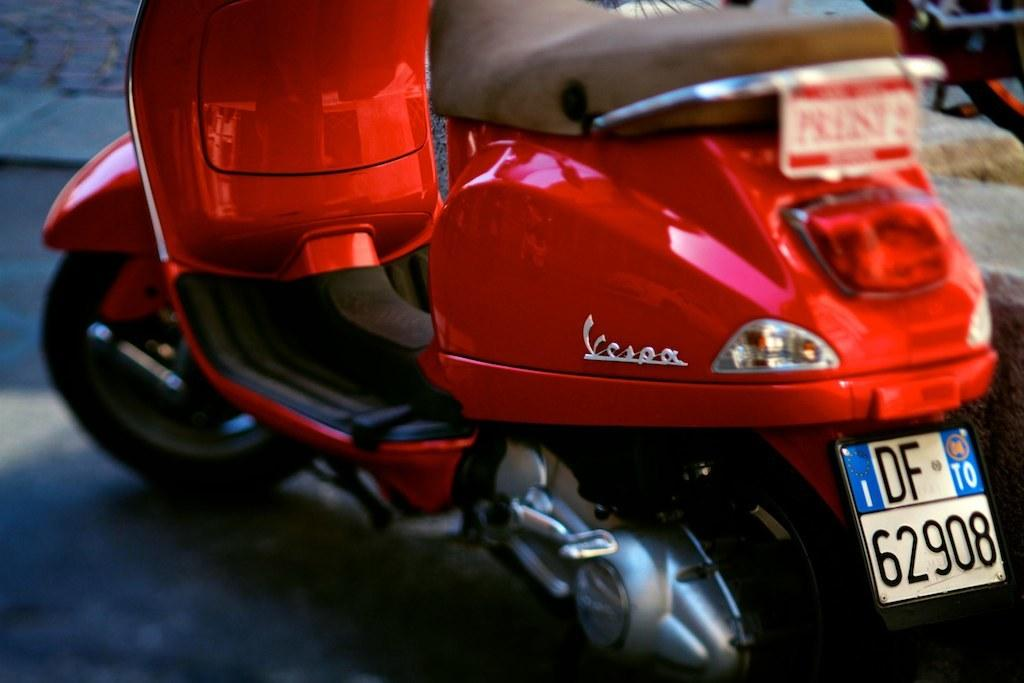What is the main subject of the image? The main subject of the image is a motorbike. Can you describe any specific features of the motorbike? Yes, the motorbike has a number plate. Where is the motorbike located in the image? The motorbike is on a path. What else can be seen in the image besides the motorbike? There is a walkway in the top left corner of the image, and there are objects visible in the top right of the image. What type of dress is the partner wearing in the image? There is no partner or dress present in the image; it features a motorbike on a path. How many quarters can be seen in the image? There are no quarters visible in the image. 